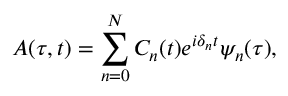<formula> <loc_0><loc_0><loc_500><loc_500>A ( \tau , t ) = \sum _ { n = 0 } ^ { N } C _ { n } ( t ) e ^ { i \delta _ { n } t } { \psi } _ { n } ( \tau ) ,</formula> 